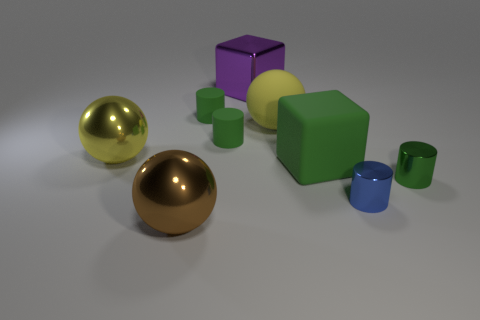There is a big metallic object that is in front of the green rubber cube; is its shape the same as the small green thing that is in front of the big yellow metal object?
Provide a short and direct response. No. Is there any other thing that has the same shape as the large green object?
Ensure brevity in your answer.  Yes. There is a big purple thing that is made of the same material as the brown ball; what is its shape?
Offer a terse response. Cube. Are there an equal number of small blue metallic things that are to the right of the small blue metallic cylinder and large red shiny things?
Provide a succinct answer. Yes. Does the yellow sphere that is on the left side of the large purple shiny object have the same material as the thing to the right of the blue metal cylinder?
Offer a terse response. Yes. The small green thing that is in front of the cube that is in front of the rubber ball is what shape?
Ensure brevity in your answer.  Cylinder. The other small cylinder that is the same material as the small blue cylinder is what color?
Give a very brief answer. Green. Is the color of the matte cube the same as the big matte sphere?
Provide a short and direct response. No. What shape is the purple object that is the same size as the green rubber block?
Ensure brevity in your answer.  Cube. How big is the yellow matte thing?
Ensure brevity in your answer.  Large. 